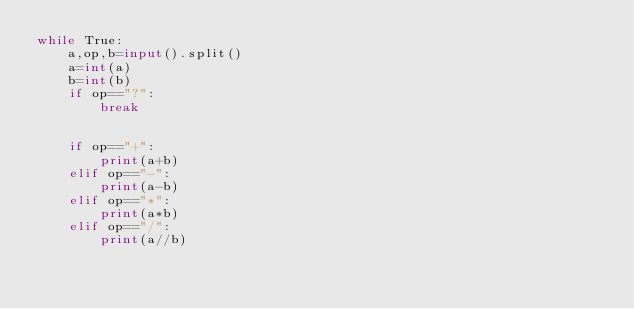<code> <loc_0><loc_0><loc_500><loc_500><_Python_>while True:
    a,op,b=input().split()
    a=int(a)
    b=int(b)
    if op=="?":
        break

    
    if op=="+":
        print(a+b)
    elif op=="-":
        print(a-b)
    elif op=="*":
        print(a*b) 
    elif op=="/":
        print(a//b)
    
</code> 